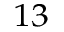<formula> <loc_0><loc_0><loc_500><loc_500>^ { 1 3 }</formula> 